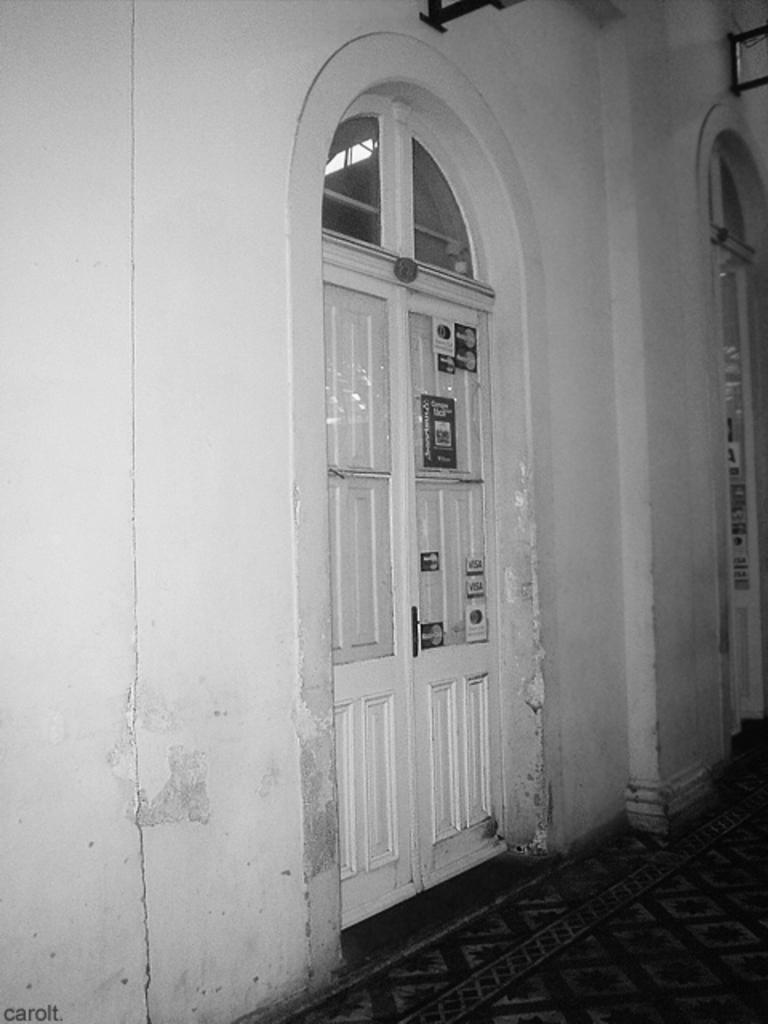What type of structure can be seen in the image? There is a wall in the image. Is there any entrance visible in the image? Yes, there is a door in the image. What is on the floor in the image? There is a carpet on the floor in the image. How many laborers are working on the patch in the image? There are no laborers or patches present in the image. 